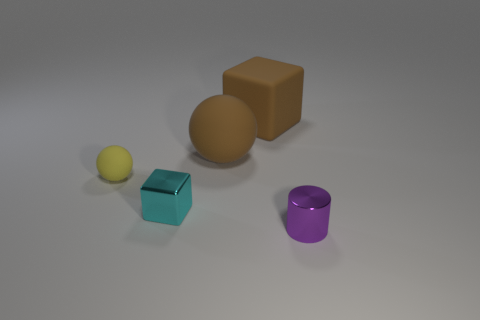Do the brown thing left of the matte cube and the block in front of the large matte cube have the same material?
Give a very brief answer. No. Are any big brown cubes visible?
Make the answer very short. Yes. Is the shape of the cyan thing that is in front of the tiny yellow rubber sphere the same as the tiny object that is in front of the cyan cube?
Give a very brief answer. No. Are there any yellow balls that have the same material as the tiny cyan block?
Your response must be concise. No. Do the ball to the left of the brown rubber sphere and the purple cylinder have the same material?
Your answer should be very brief. No. Are there more yellow matte balls in front of the shiny cylinder than yellow matte spheres that are to the left of the tiny yellow sphere?
Make the answer very short. No. What color is the other shiny object that is the same size as the cyan object?
Give a very brief answer. Purple. Are there any small cylinders that have the same color as the large sphere?
Provide a succinct answer. No. There is a matte ball on the right side of the small rubber object; is it the same color as the metal thing behind the tiny purple cylinder?
Your answer should be very brief. No. What is the brown thing that is right of the big rubber sphere made of?
Your response must be concise. Rubber. 